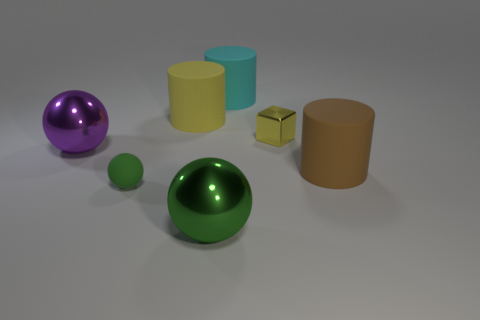Subtract 1 cylinders. How many cylinders are left? 2 Add 2 gray matte cylinders. How many objects exist? 9 Subtract all cylinders. How many objects are left? 4 Add 5 big cyan cylinders. How many big cyan cylinders are left? 6 Add 2 big yellow objects. How many big yellow objects exist? 3 Subtract 0 green cylinders. How many objects are left? 7 Subtract all large things. Subtract all large cyan metal balls. How many objects are left? 2 